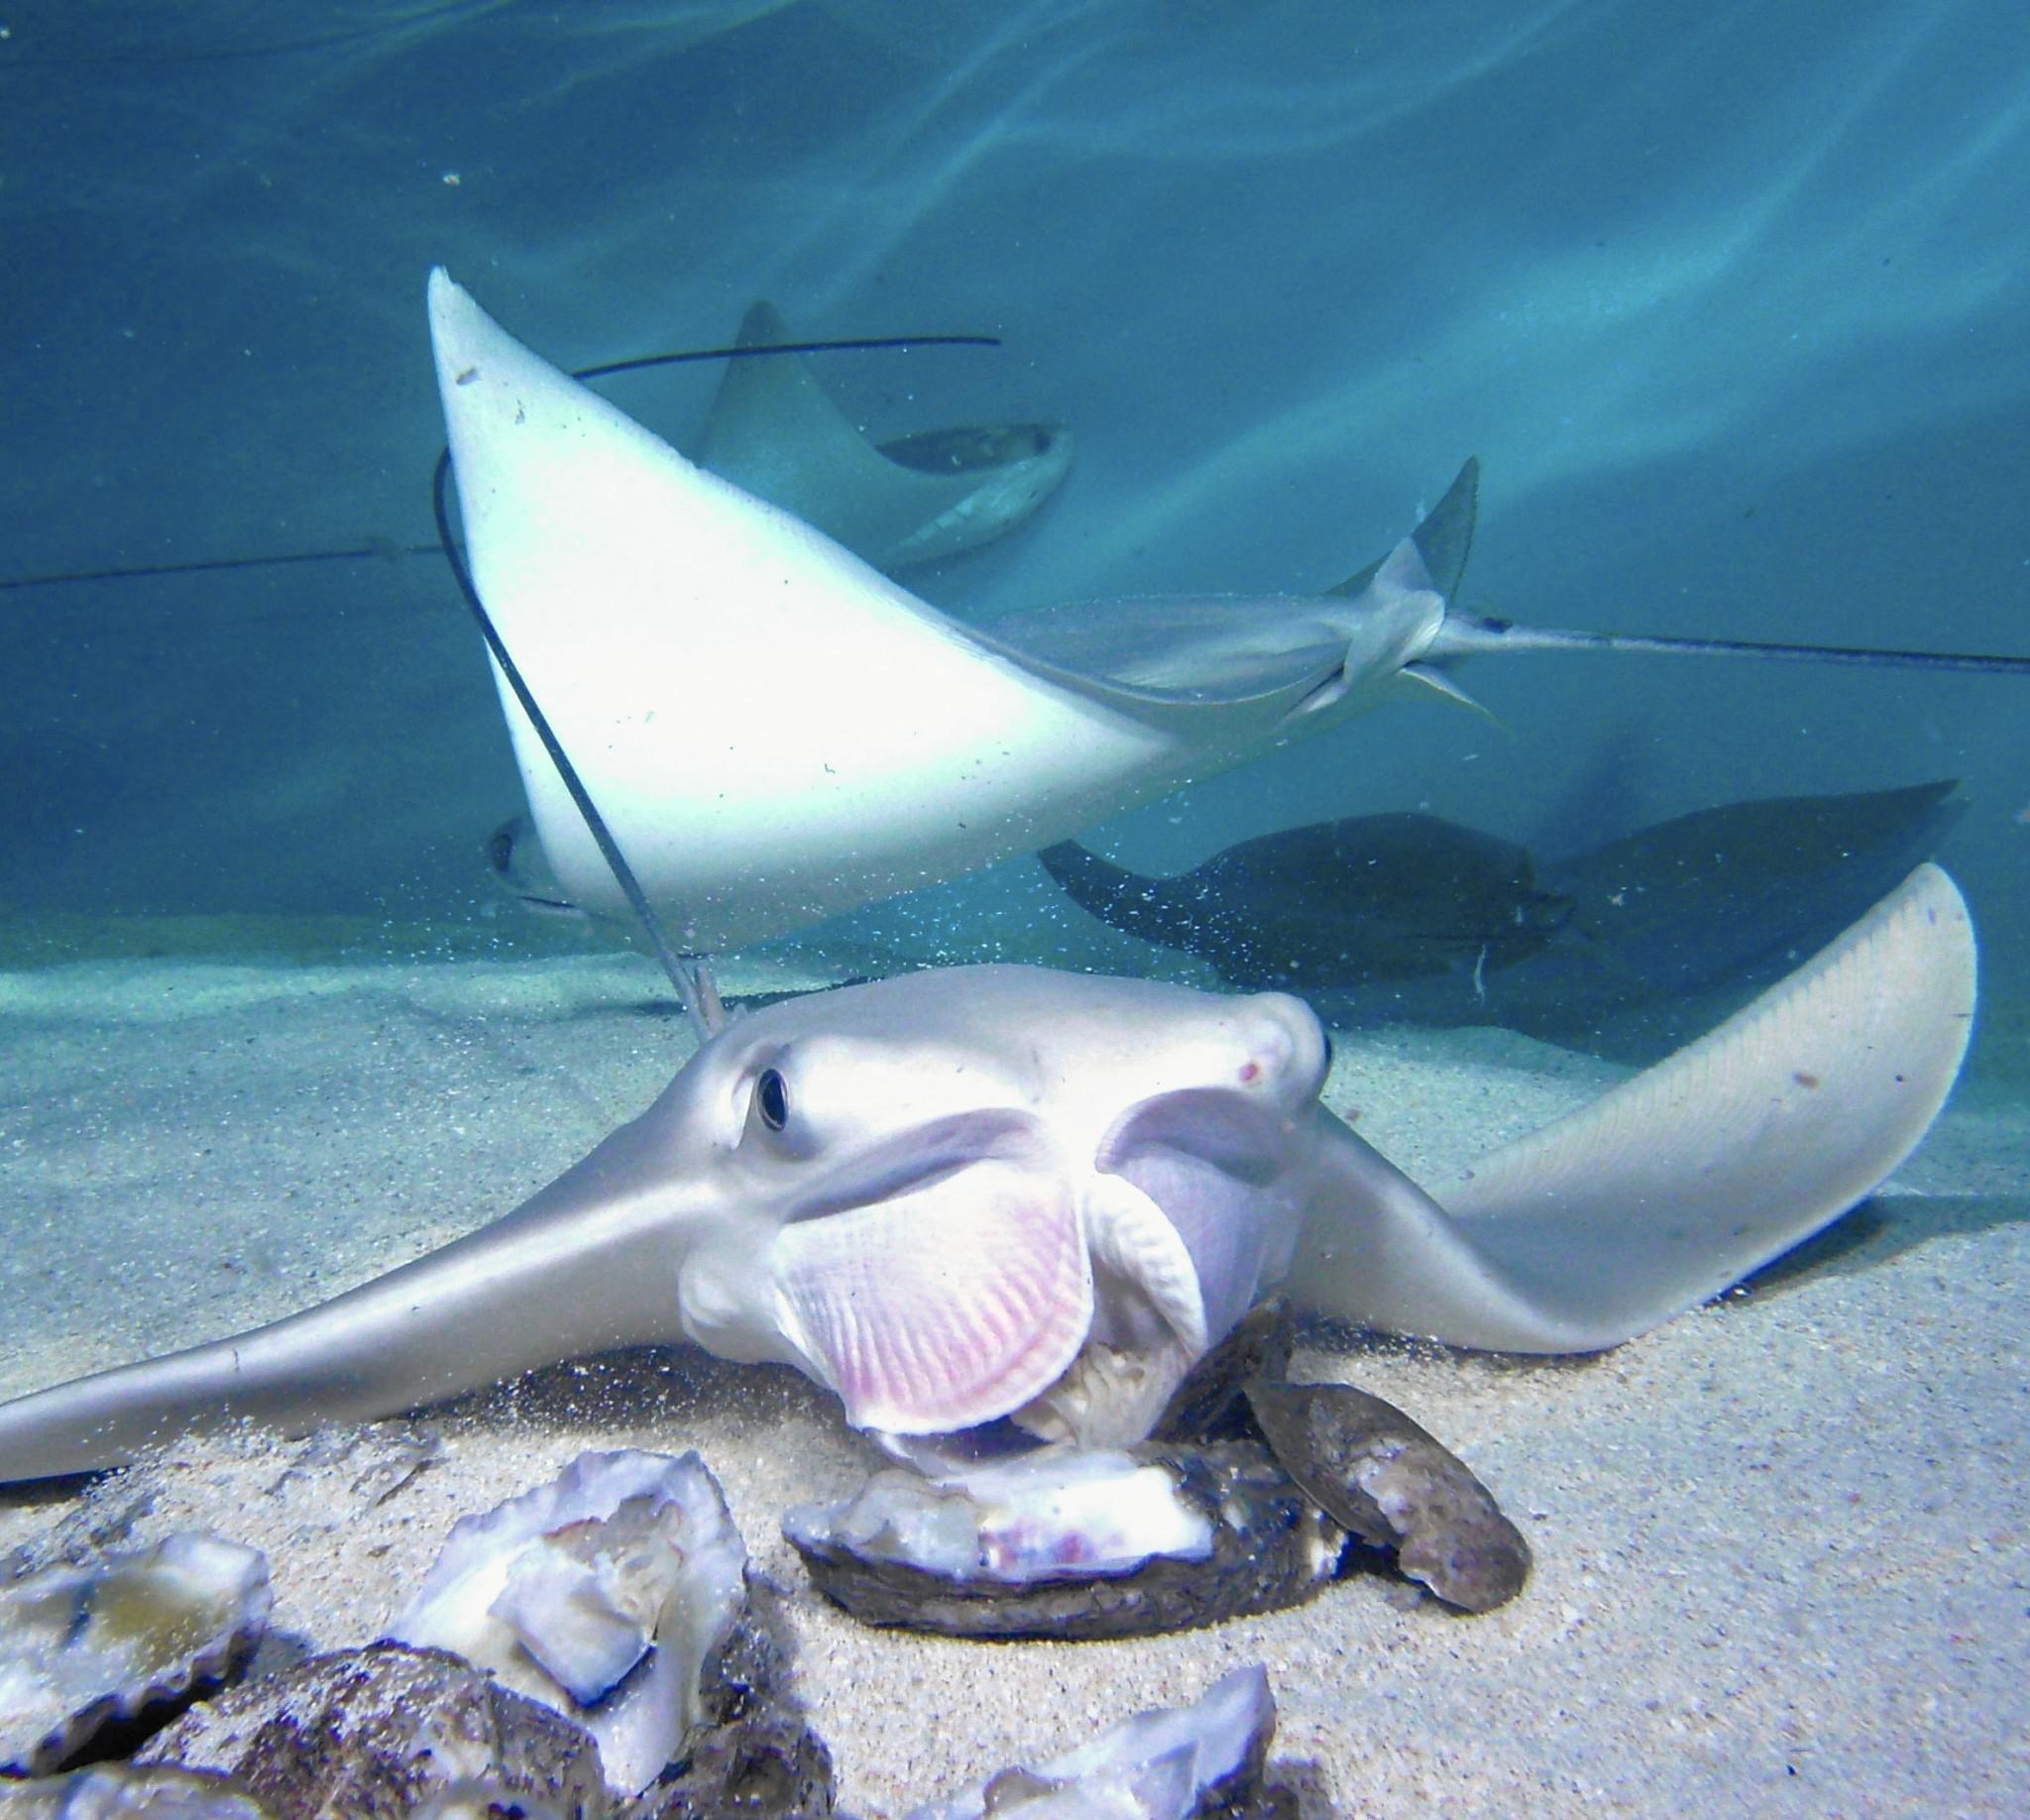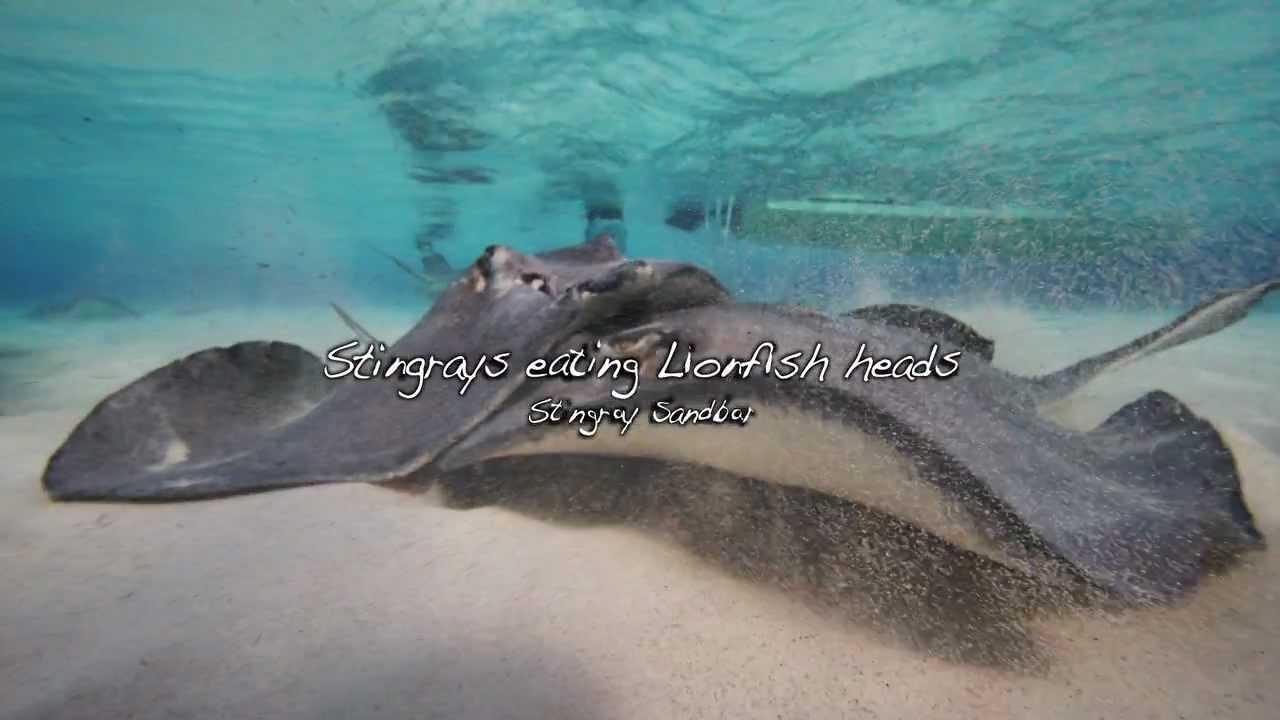The first image is the image on the left, the second image is the image on the right. Examine the images to the left and right. Is the description "In exactly one of the images a stingray is eating clams." accurate? Answer yes or no. Yes. The first image is the image on the left, the second image is the image on the right. Given the left and right images, does the statement "One image appears to show one stingray on top of another stingray, and the other image shows at least one stingray positioned over oyster-like shells." hold true? Answer yes or no. Yes. 